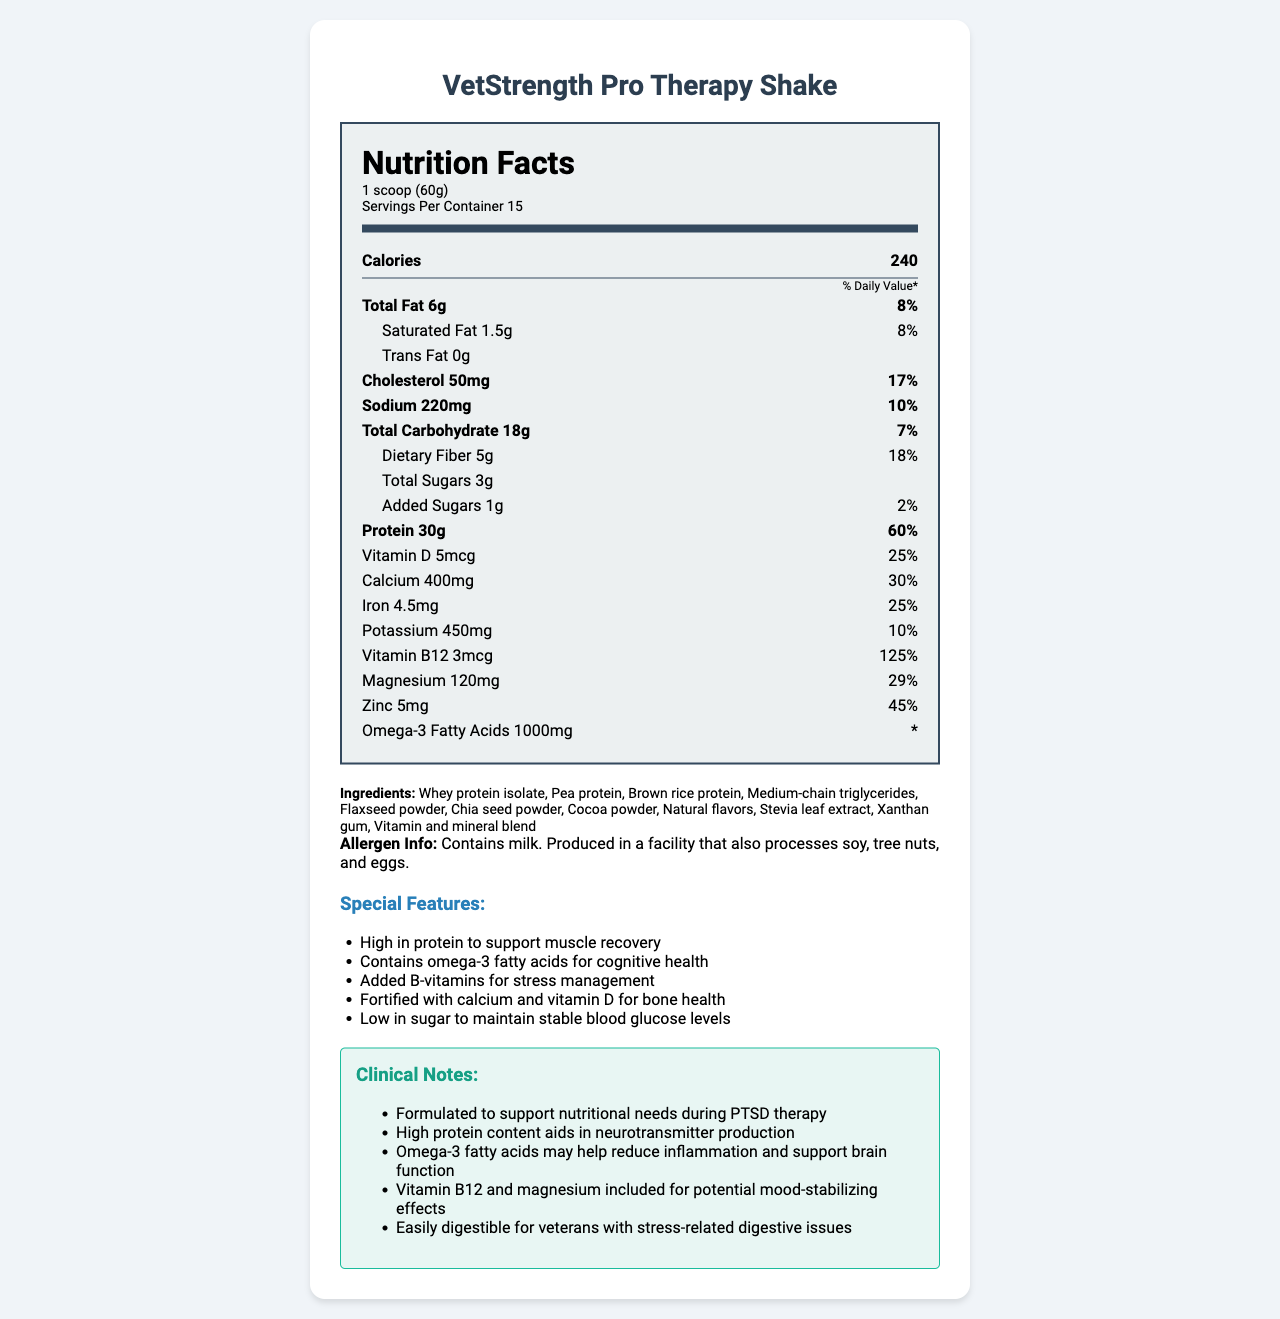what is the name of the product? The product name is clearly listed at the top of the document.
Answer: VetStrength Pro Therapy Shake what is the serving size of VetStrength Pro Therapy Shake? The serving size is mentioned in the serving info section of the Nutrition Facts label.
Answer: 1 scoop (60g) how many servings are there in one container of the shake? The document states "Servings Per Container 15" in the serving info section.
Answer: 15 how many grams of protein does each serving contain? The protein content is listed as "Protein 30g" in the nutrient information section.
Answer: 30g what is the daily value percentage for saturated fat? The daily value for saturated fat is listed as "Saturated Fat 1.5g 8%" in the nutrient information section.
Answer: 8% how much calcium is in each serving? The calcium content is mentioned as "Calcium 400mg" in the nutrient information section.
Answer: 400mg what is the total carbohydrate content per serving? The total carbohydrate amount is listed as "Total Carbohydrate 18g" in the nutrient information section.
Answer: 18g what are the ingredients in the VetStrength Pro Therapy Shake? The document lists the ingredients in the ingredients section.
Answer: Whey protein isolate, Pea protein, Brown rice protein, Medium-chain triglycerides, Flaxseed powder, Chia seed powder, Cocoa powder, Natural flavors, Stevia leaf extract, Xanthan gum, Vitamin and mineral blend which of the following is a feature of the shake? A. High sugar content B. Low in protein C. Contains omega-3 fatty acids D. High sodium content Contains omega-3 fatty acids is one of the special features listed in the features section.
Answer: C how much fiber does the shake provide per serving? A. 3g B. 4g C. 5g D. 6g The dietary fiber content per serving is listed as "Dietary Fiber 5g" in the nutrient information section.
Answer: C is the shake suitable for individuals avoiding milk? The allergen info states "Contains milk," making it unsuitable for those avoiding milk.
Answer: No does the shake include any added sugars? The nutrient information includes "Added Sugars 1g" indicating the presence of added sugars.
Answer: Yes what is the primary purpose of this shake according to the clinical notes? The clinical notes section explicitly mentions that the shake is formulated to support nutritional needs during PTSD therapy.
Answer: To support nutritional needs during PTSD therapy summarize the main features and purposes of VetStrength Pro Therapy Shake. This summary touches on the main features, nutrients, and clinical notes provided in the document, covering both the nutritional and therapeutic aspects comprehensively.
Answer: The VetStrength Pro Therapy Shake is a high-protein meal replacement designed to support muscle recovery and cognitive health. It includes omega-3 fatty acids, B-vitamins, calcium, vitamin D, and magnesium for various health benefits. It is particularly formulated to address nutritional needs during PTSD therapy, aiding neurotransmitter production and potentially mood stabilization, while being easily digestible for veterans with stress-related digestive issues. The shake contains 240 calories per serving, with essential nutrients and is low in sugars. what is the exact amount of trans fat in the shake? The nutrient information clearly states "Trans Fat 0g."
Answer: 0g how does vitamin B12 in the shake help veterans? The document states that vitamin B12 is included for potential mood-stabilizing effects, but it does not provide detailed information on how it specifically helps veterans.
Answer: Cannot be determined 